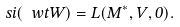Convert formula to latex. <formula><loc_0><loc_0><loc_500><loc_500>\ s i ( \ w t { W } ) = L ( M ^ { * } , V , 0 ) .</formula> 